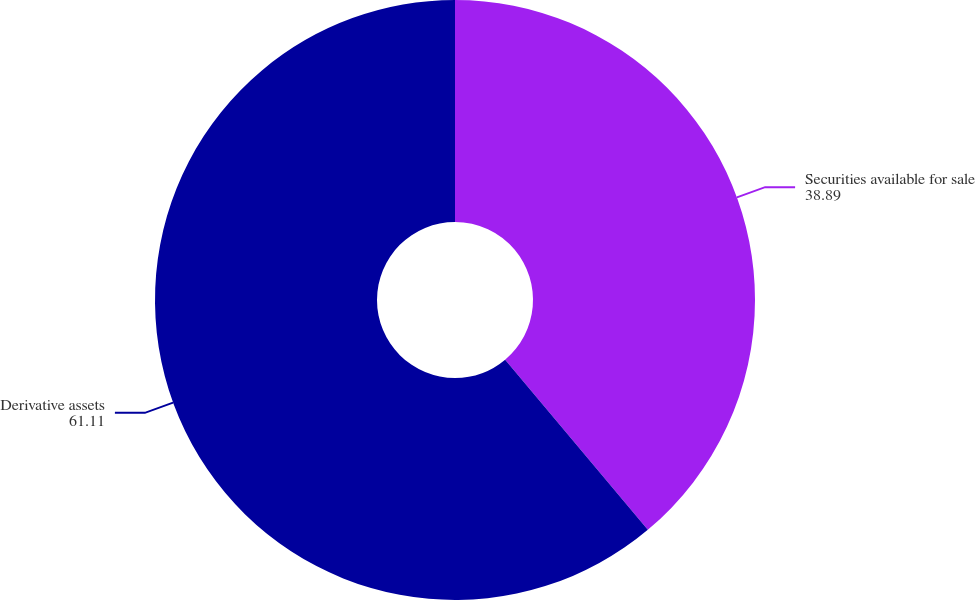Convert chart. <chart><loc_0><loc_0><loc_500><loc_500><pie_chart><fcel>Securities available for sale<fcel>Derivative assets<nl><fcel>38.89%<fcel>61.11%<nl></chart> 